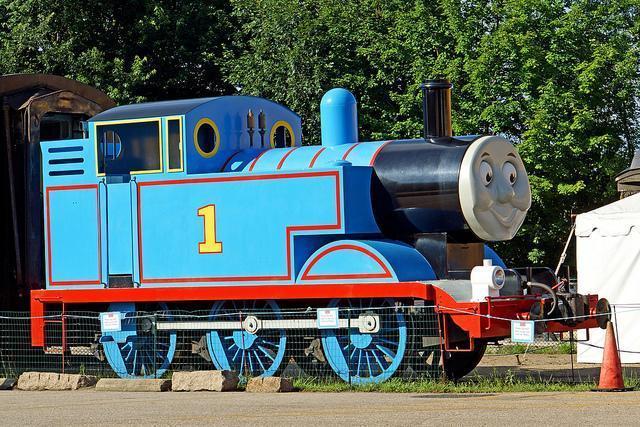How many safety cones are in the photo?
Give a very brief answer. 1. How many light rimmed wheels are shown?
Give a very brief answer. 3. 